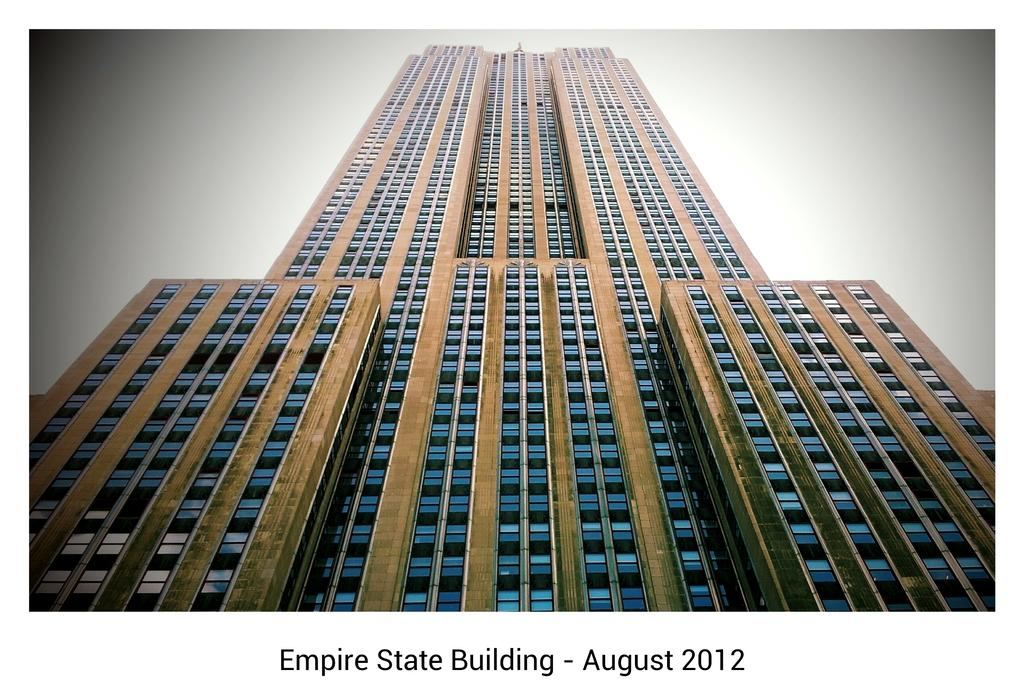What is the main structure in the center of the image? There is a building in the center of the image. What type of architectural feature can be seen in the image? There is a wall in the image. What material is used for the wall? The wall appears to be made of glass. What else can be seen in the image besides the building and wall? There are other objects in the image. What information is provided at the bottom of the image? There is text at the bottom of the image. How would you describe the background of the image? The background of the image is blurred. How many eggs are visible in the image? There are no eggs present in the image. What type of pipe can be seen connecting the building to the airport? There is no pipe connecting the building to an airport in the image, nor is there an airport present. 